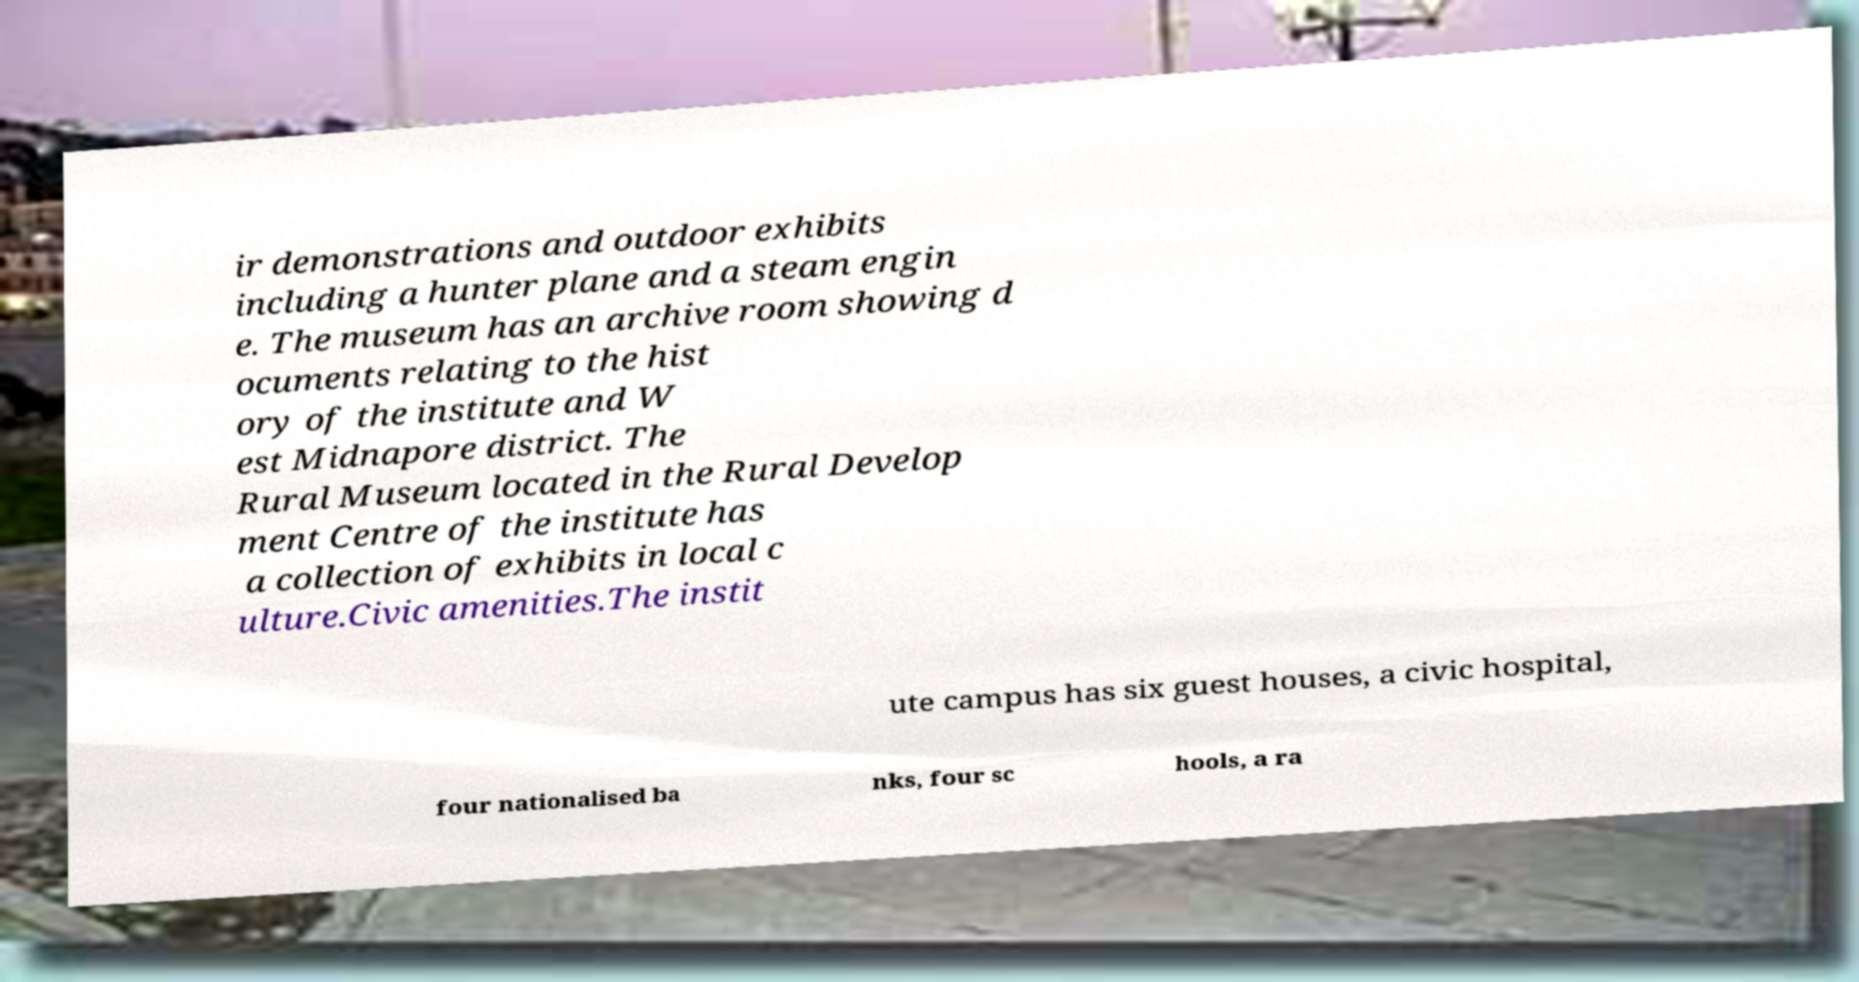Can you accurately transcribe the text from the provided image for me? ir demonstrations and outdoor exhibits including a hunter plane and a steam engin e. The museum has an archive room showing d ocuments relating to the hist ory of the institute and W est Midnapore district. The Rural Museum located in the Rural Develop ment Centre of the institute has a collection of exhibits in local c ulture.Civic amenities.The instit ute campus has six guest houses, a civic hospital, four nationalised ba nks, four sc hools, a ra 